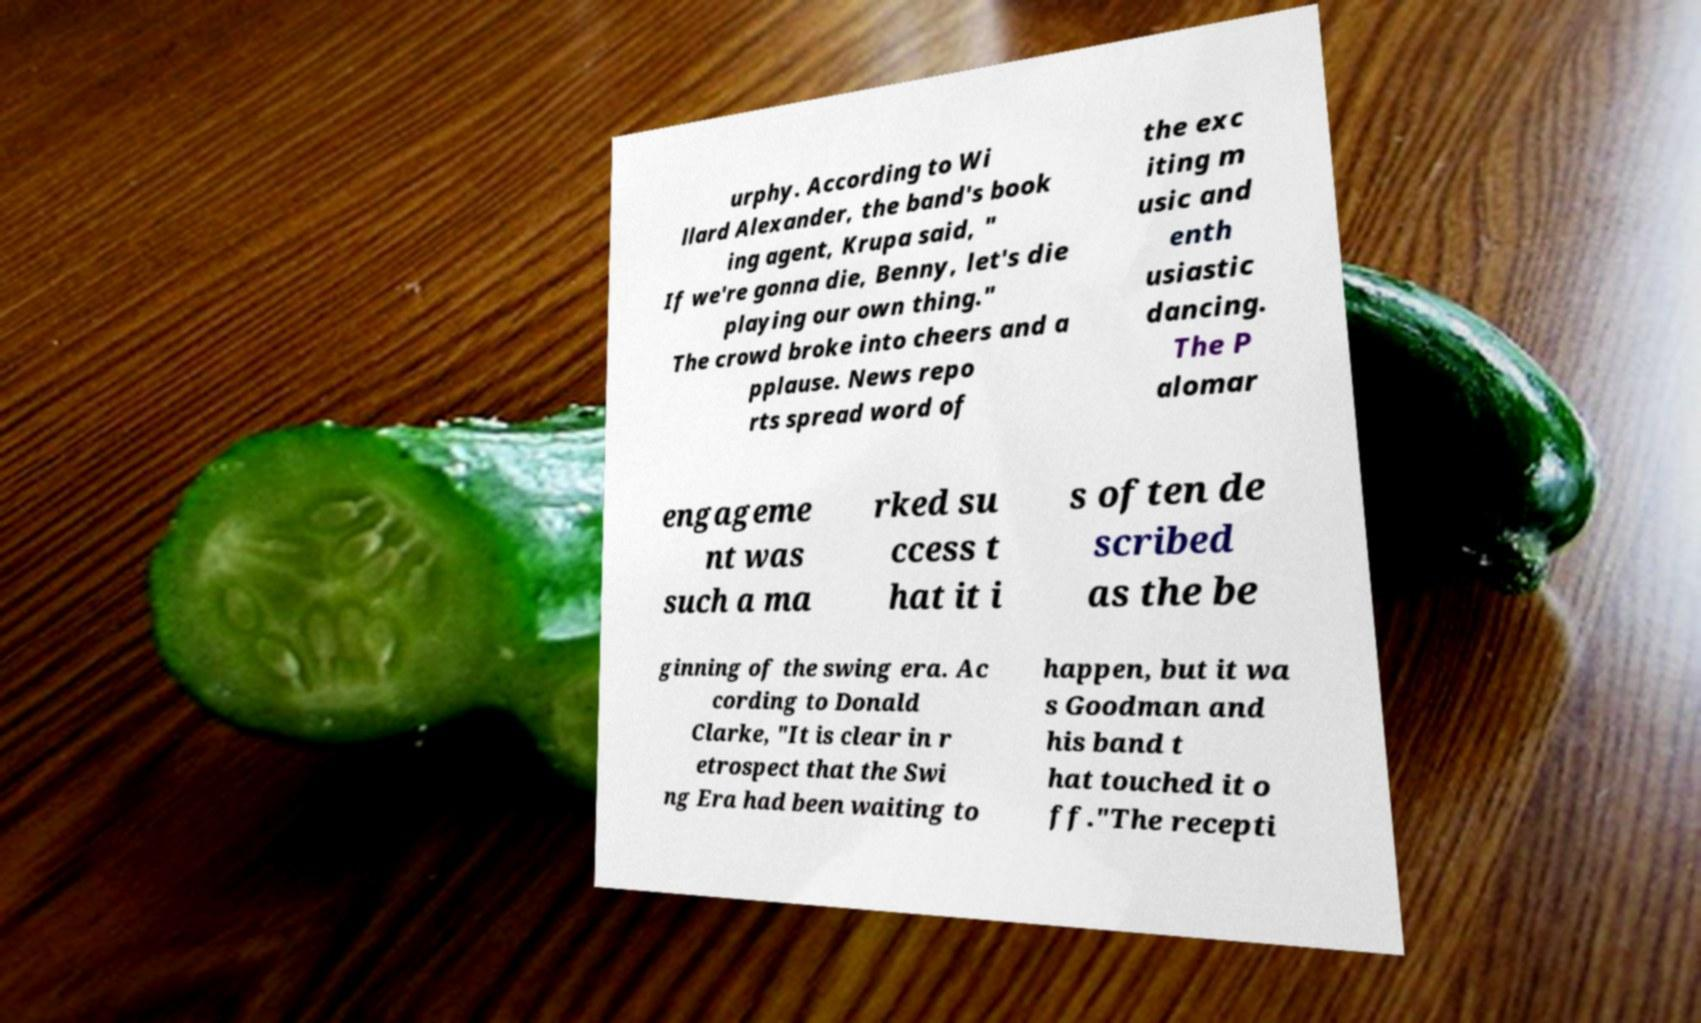I need the written content from this picture converted into text. Can you do that? urphy. According to Wi llard Alexander, the band's book ing agent, Krupa said, " If we're gonna die, Benny, let's die playing our own thing." The crowd broke into cheers and a pplause. News repo rts spread word of the exc iting m usic and enth usiastic dancing. The P alomar engageme nt was such a ma rked su ccess t hat it i s often de scribed as the be ginning of the swing era. Ac cording to Donald Clarke, "It is clear in r etrospect that the Swi ng Era had been waiting to happen, but it wa s Goodman and his band t hat touched it o ff."The recepti 